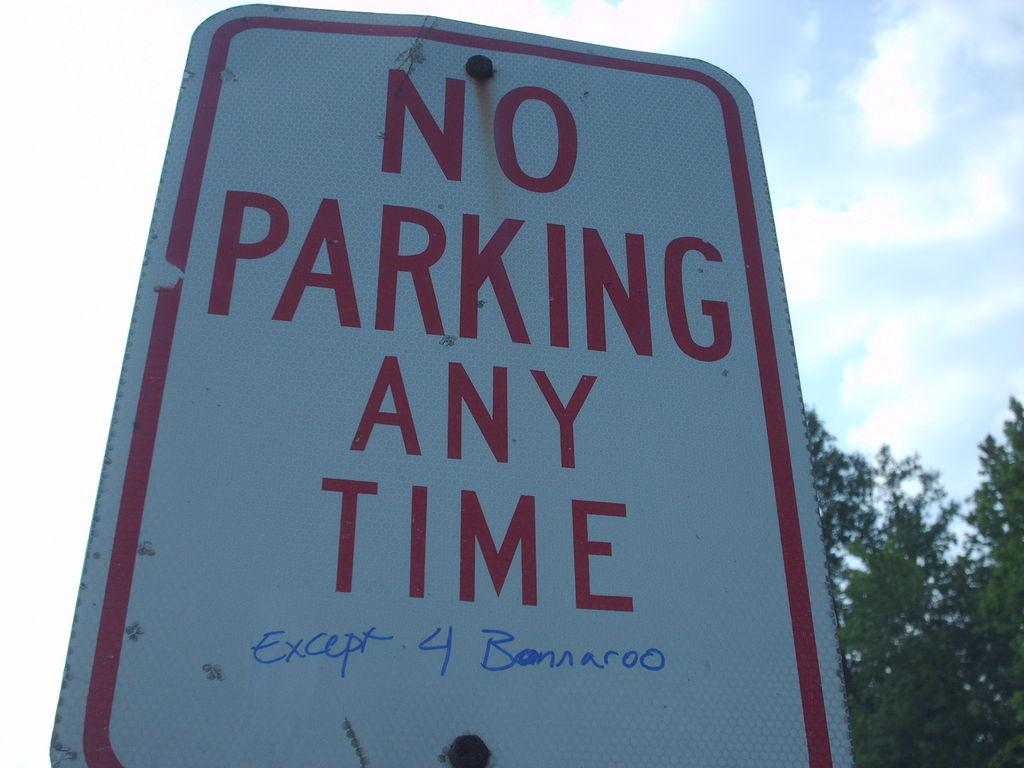<image>
Give a short and clear explanation of the subsequent image. A No parking anytime sign on which someone has hand written Except 4 Bannaroo. 